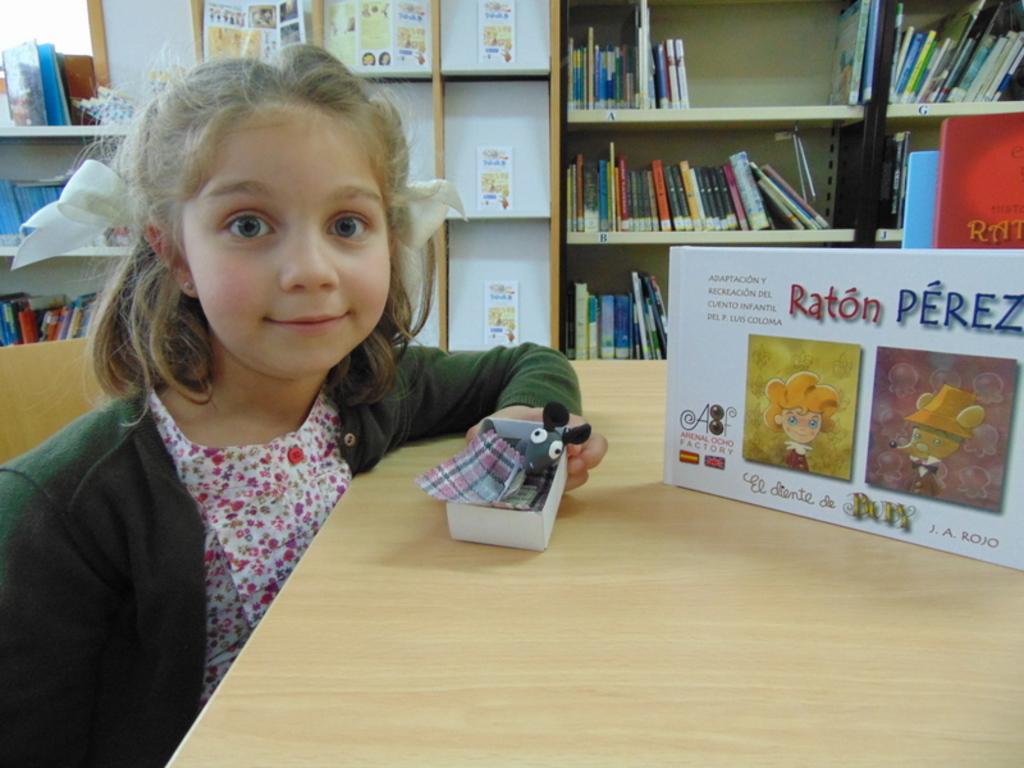What series is the character from that the little girl is holding?
Give a very brief answer. Raton perez. What is the title of the display on the table/?
Your answer should be very brief. Raton perez. 